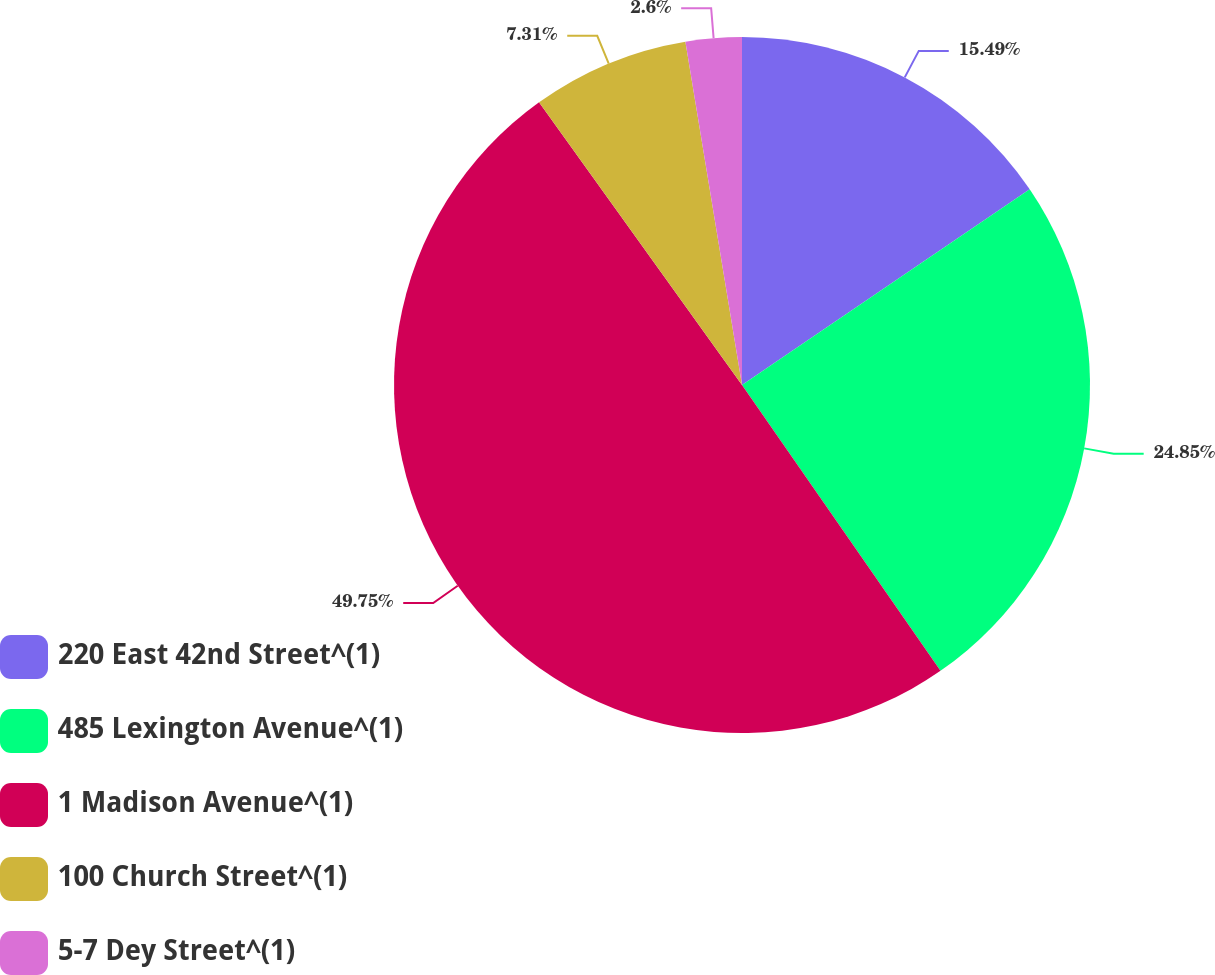<chart> <loc_0><loc_0><loc_500><loc_500><pie_chart><fcel>220 East 42nd Street^(1)<fcel>485 Lexington Avenue^(1)<fcel>1 Madison Avenue^(1)<fcel>100 Church Street^(1)<fcel>5-7 Dey Street^(1)<nl><fcel>15.49%<fcel>24.85%<fcel>49.75%<fcel>7.31%<fcel>2.6%<nl></chart> 